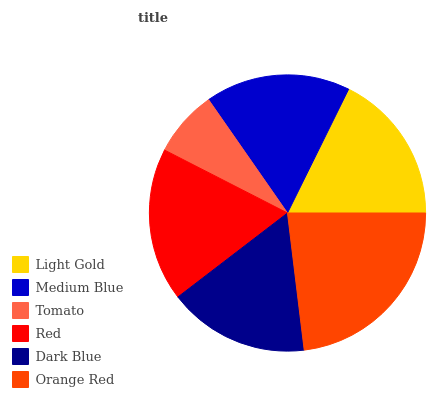Is Tomato the minimum?
Answer yes or no. Yes. Is Orange Red the maximum?
Answer yes or no. Yes. Is Medium Blue the minimum?
Answer yes or no. No. Is Medium Blue the maximum?
Answer yes or no. No. Is Light Gold greater than Medium Blue?
Answer yes or no. Yes. Is Medium Blue less than Light Gold?
Answer yes or no. Yes. Is Medium Blue greater than Light Gold?
Answer yes or no. No. Is Light Gold less than Medium Blue?
Answer yes or no. No. Is Light Gold the high median?
Answer yes or no. Yes. Is Medium Blue the low median?
Answer yes or no. Yes. Is Tomato the high median?
Answer yes or no. No. Is Tomato the low median?
Answer yes or no. No. 